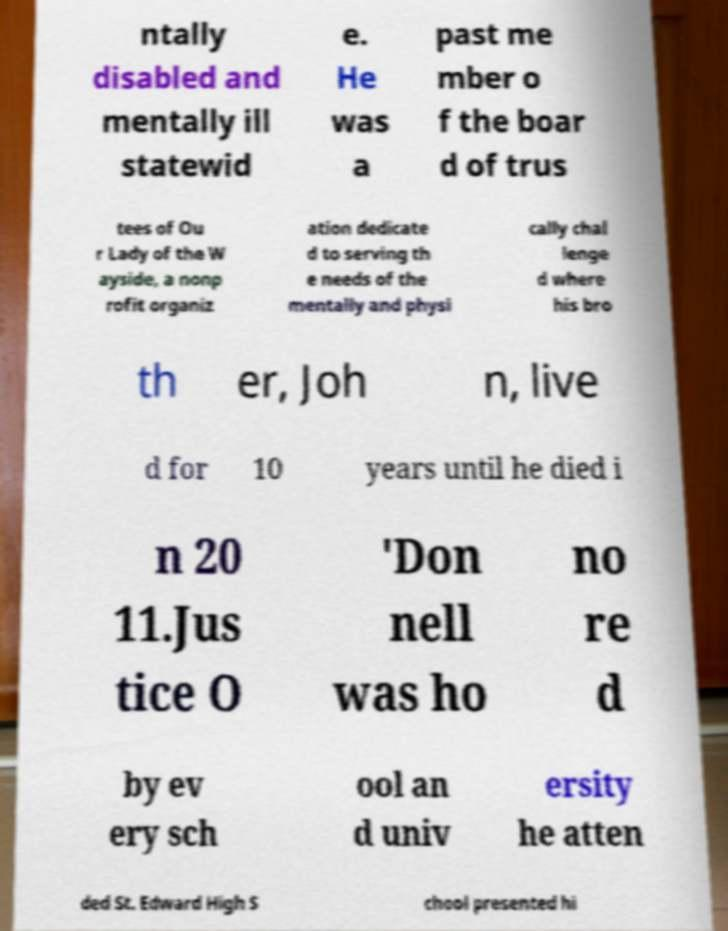There's text embedded in this image that I need extracted. Can you transcribe it verbatim? ntally disabled and mentally ill statewid e. He was a past me mber o f the boar d of trus tees of Ou r Lady of the W ayside, a nonp rofit organiz ation dedicate d to serving th e needs of the mentally and physi cally chal lenge d where his bro th er, Joh n, live d for 10 years until he died i n 20 11.Jus tice O 'Don nell was ho no re d by ev ery sch ool an d univ ersity he atten ded St. Edward High S chool presented hi 